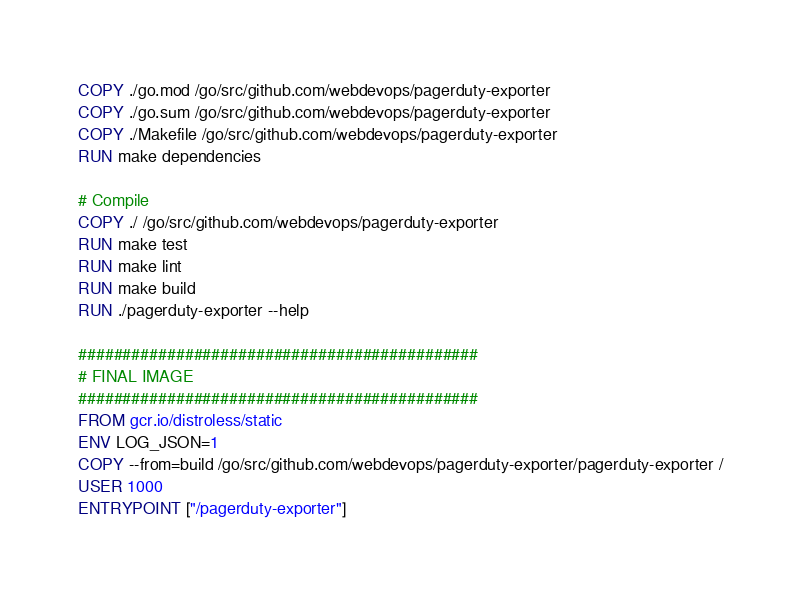Convert code to text. <code><loc_0><loc_0><loc_500><loc_500><_Dockerfile_>COPY ./go.mod /go/src/github.com/webdevops/pagerduty-exporter
COPY ./go.sum /go/src/github.com/webdevops/pagerduty-exporter
COPY ./Makefile /go/src/github.com/webdevops/pagerduty-exporter
RUN make dependencies

# Compile
COPY ./ /go/src/github.com/webdevops/pagerduty-exporter
RUN make test
RUN make lint
RUN make build
RUN ./pagerduty-exporter --help

#############################################
# FINAL IMAGE
#############################################
FROM gcr.io/distroless/static
ENV LOG_JSON=1
COPY --from=build /go/src/github.com/webdevops/pagerduty-exporter/pagerduty-exporter /
USER 1000
ENTRYPOINT ["/pagerduty-exporter"]
</code> 